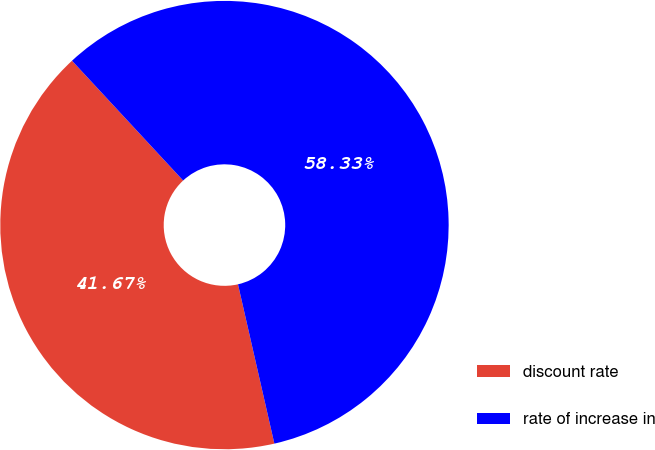Convert chart to OTSL. <chart><loc_0><loc_0><loc_500><loc_500><pie_chart><fcel>discount rate<fcel>rate of increase in<nl><fcel>41.67%<fcel>58.33%<nl></chart> 